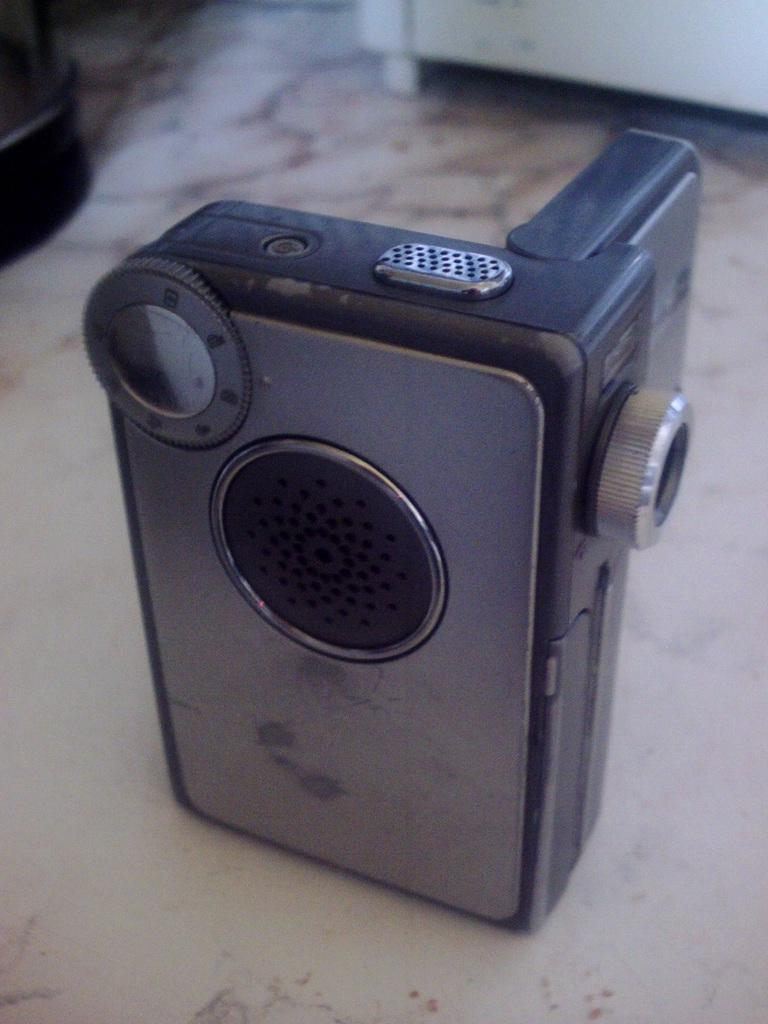What is the main subject in the center of the image? There is a camera in the center of the image. What type of bag is being used to carry the camera in the image? There is no bag present in the image; the camera is the main subject. 